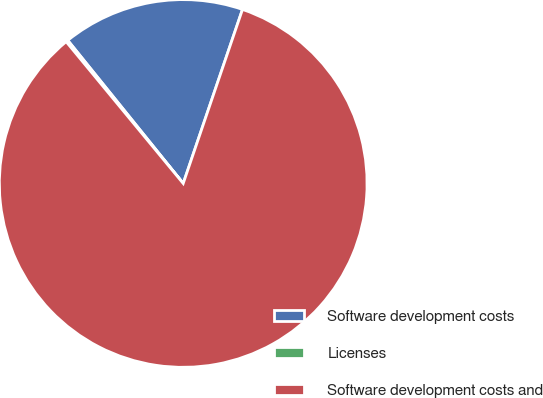Convert chart to OTSL. <chart><loc_0><loc_0><loc_500><loc_500><pie_chart><fcel>Software development costs<fcel>Licenses<fcel>Software development costs and<nl><fcel>16.03%<fcel>0.18%<fcel>83.8%<nl></chart> 